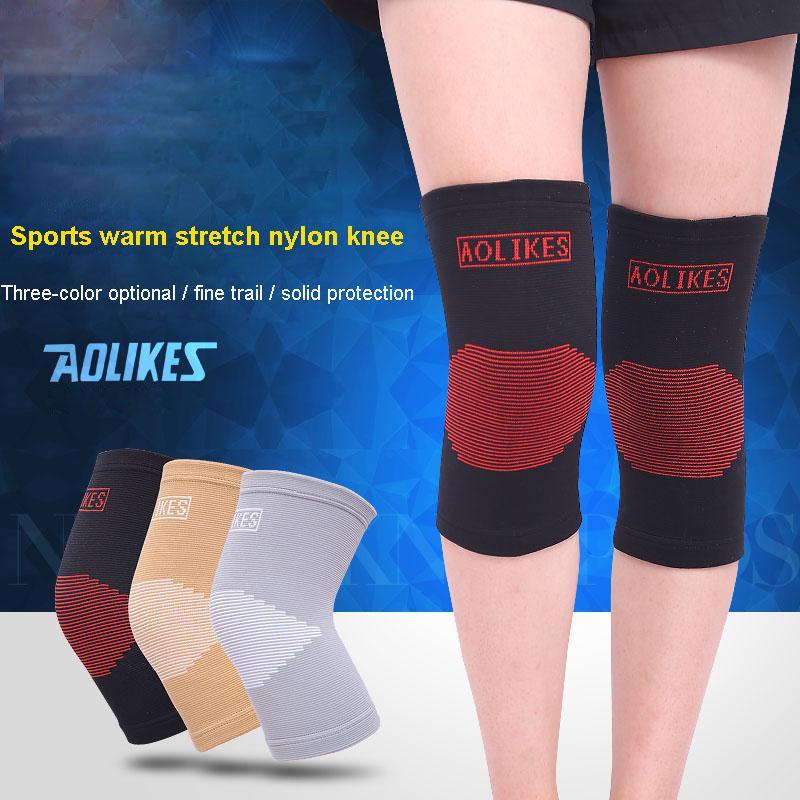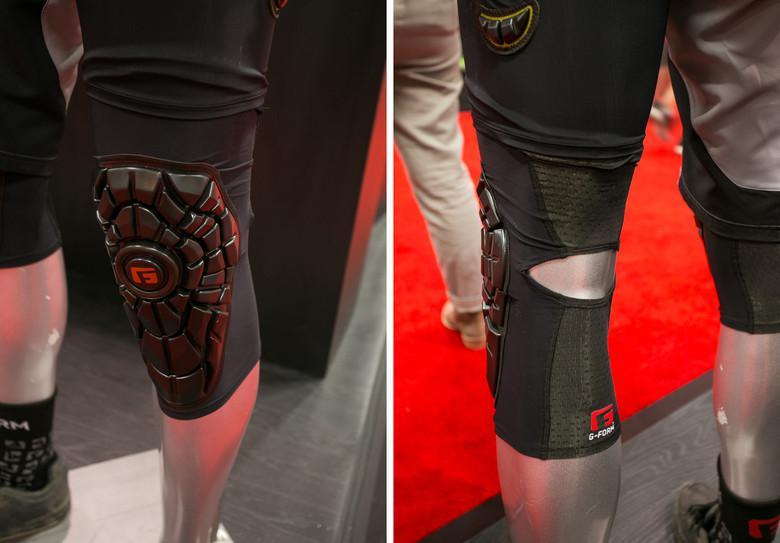The first image is the image on the left, the second image is the image on the right. Evaluate the accuracy of this statement regarding the images: "All images show legs wearing kneepads.". Is it true? Answer yes or no. Yes. 